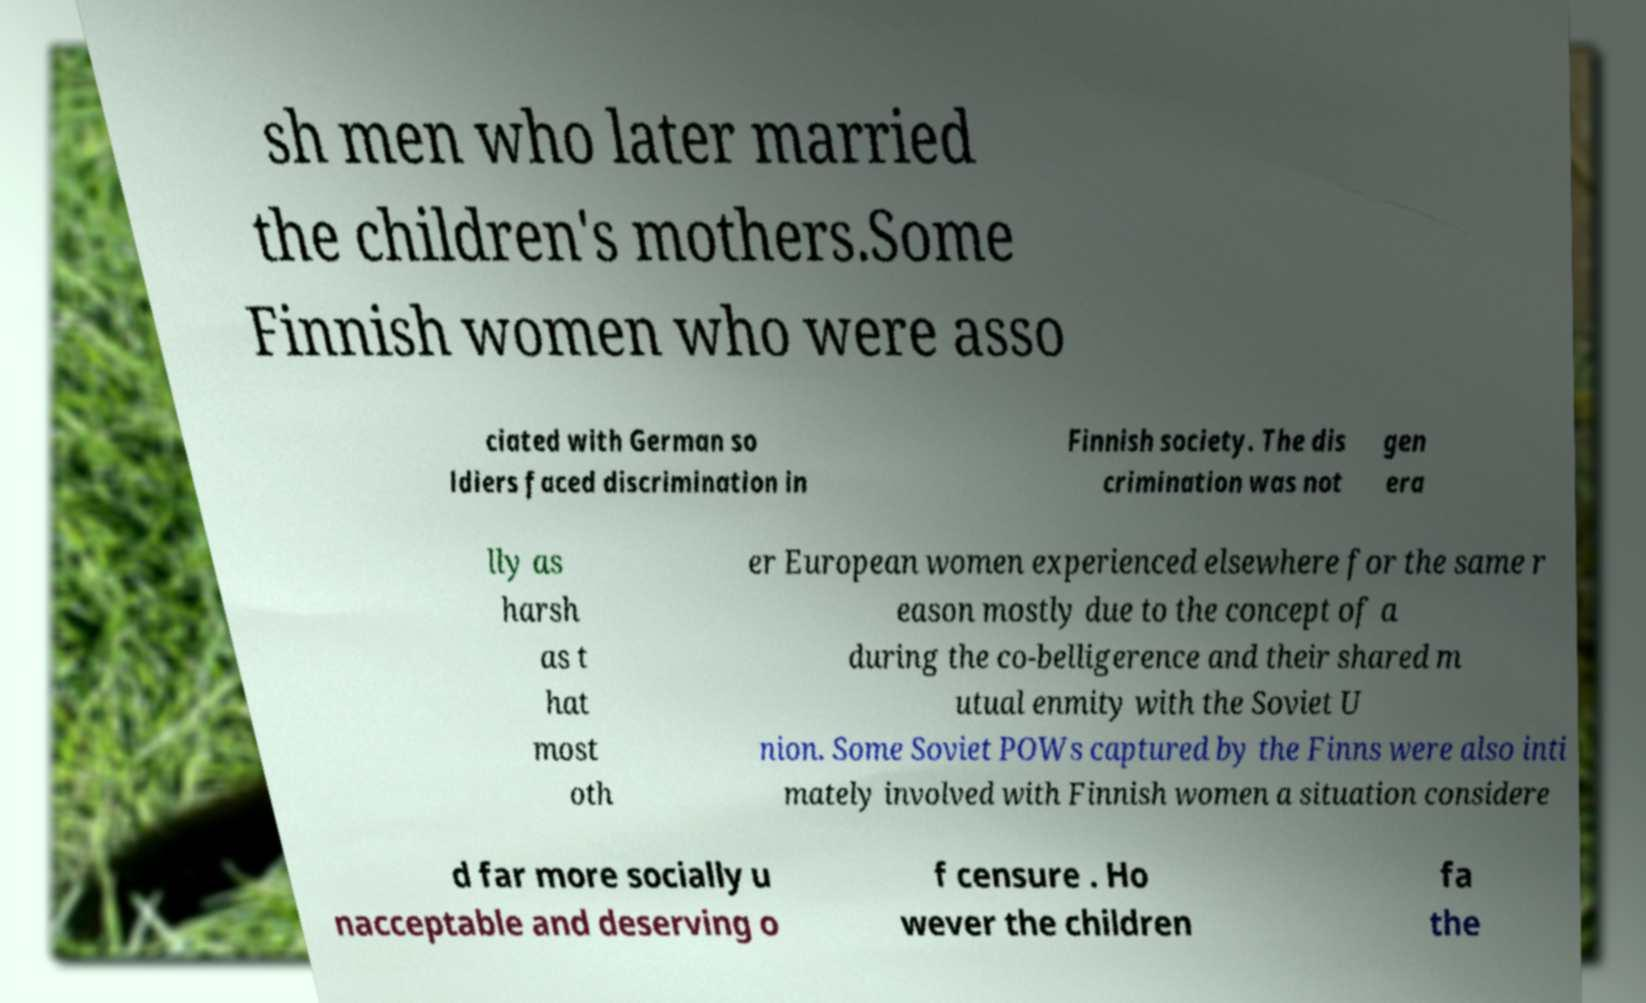I need the written content from this picture converted into text. Can you do that? sh men who later married the children's mothers.Some Finnish women who were asso ciated with German so ldiers faced discrimination in Finnish society. The dis crimination was not gen era lly as harsh as t hat most oth er European women experienced elsewhere for the same r eason mostly due to the concept of a during the co-belligerence and their shared m utual enmity with the Soviet U nion. Some Soviet POWs captured by the Finns were also inti mately involved with Finnish women a situation considere d far more socially u nacceptable and deserving o f censure . Ho wever the children fa the 